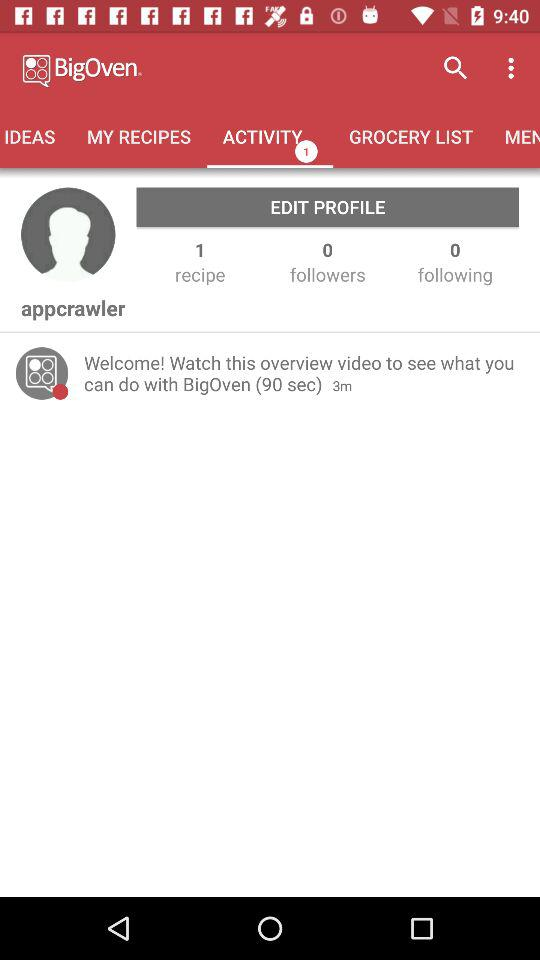How many followers does appcrawler have?
Answer the question using a single word or phrase. 0 